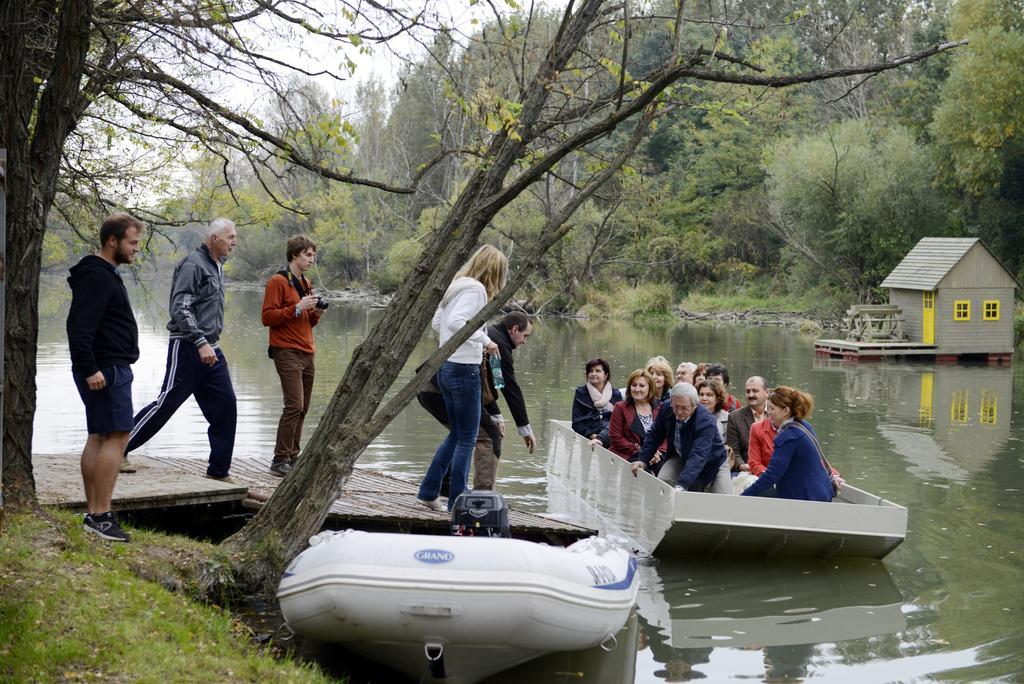In one or two sentences, can you explain what this image depicts? In this picture I can see there is a boat sailing on the water and there are few people sitting in the boat, there are few people standing on to left, one of them is holding a camera. The woman is holding water bottles, there is a building on to right and in the backdrop there are trees, plants, grass and the sky is clear. 